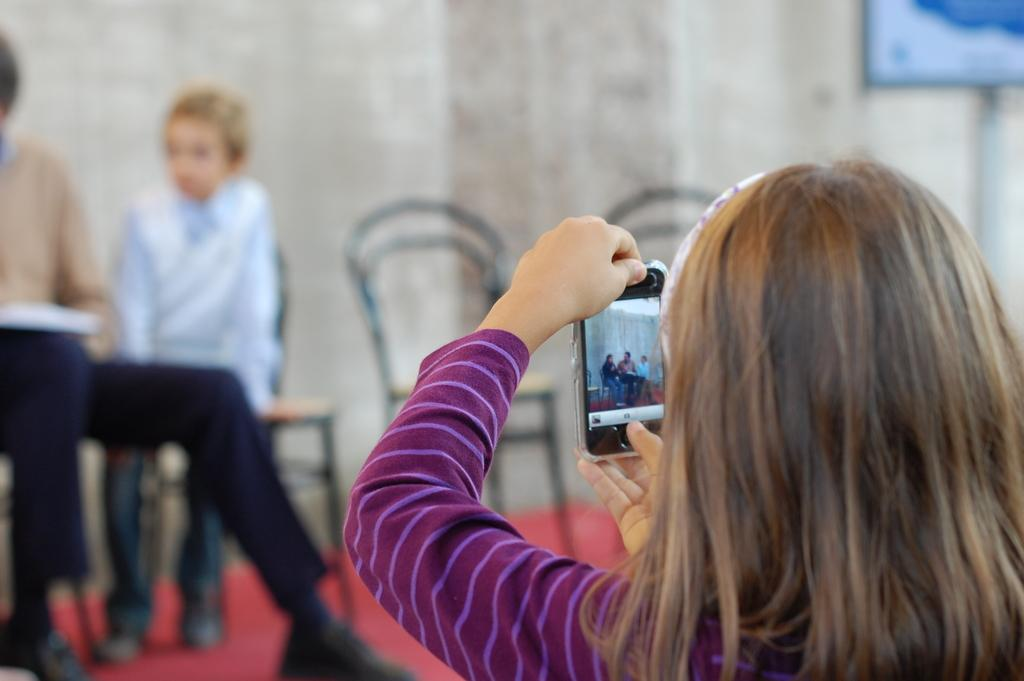Who is the main subject in the image? There is a girl in the image. What is the girl holding in the image? The girl is holding a mobile phone. What is the girl doing with her mobile phone? The girl is taking a picture of two persons sitting in front of her. Can you describe the people sitting in front of the girl? There are two persons sitting in front of the girl. What can be seen in the background of the image? There are chairs in the background of the image. What type of hope can be seen in the image? There is no reference to hope in the image; it features a girl taking a picture of two persons sitting in front of her. What design elements are present in the image? The image does not focus on design elements; it primarily shows a girl taking a picture of two persons. 